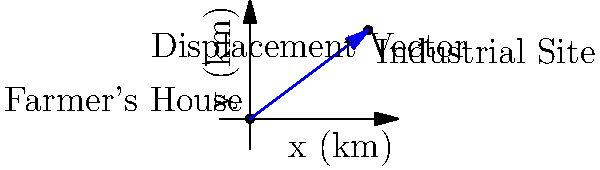A farmer's house is located at the origin (0, 0) km, and a proposed industrial site is planned to be built at coordinates (4, 3) km. Calculate the magnitude of the displacement vector from the farmer's house to the industrial site. To find the magnitude of the displacement vector, we can follow these steps:

1. Identify the coordinates:
   - Farmer's house: (0, 0) km
   - Industrial site: (4, 3) km

2. Calculate the components of the displacement vector:
   - x-component: 4 - 0 = 4 km
   - y-component: 3 - 0 = 3 km

3. Use the Pythagorean theorem to find the magnitude:
   $$|\vec{d}| = \sqrt{(x_2 - x_1)^2 + (y_2 - y_1)^2}$$
   $$|\vec{d}| = \sqrt{4^2 + 3^2}$$
   $$|\vec{d}| = \sqrt{16 + 9}$$
   $$|\vec{d}| = \sqrt{25}$$
   $$|\vec{d}| = 5$$

Therefore, the magnitude of the displacement vector is 5 km.
Answer: 5 km 